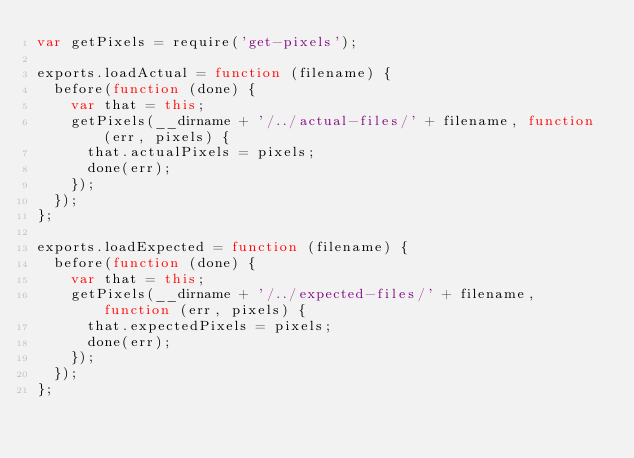Convert code to text. <code><loc_0><loc_0><loc_500><loc_500><_JavaScript_>var getPixels = require('get-pixels');

exports.loadActual = function (filename) {
  before(function (done) {
    var that = this;
    getPixels(__dirname + '/../actual-files/' + filename, function (err, pixels) {
      that.actualPixels = pixels;
      done(err);
    });
  });
};

exports.loadExpected = function (filename) {
  before(function (done) {
    var that = this;
    getPixels(__dirname + '/../expected-files/' + filename, function (err, pixels) {
      that.expectedPixels = pixels;
      done(err);
    });
  });
};
</code> 